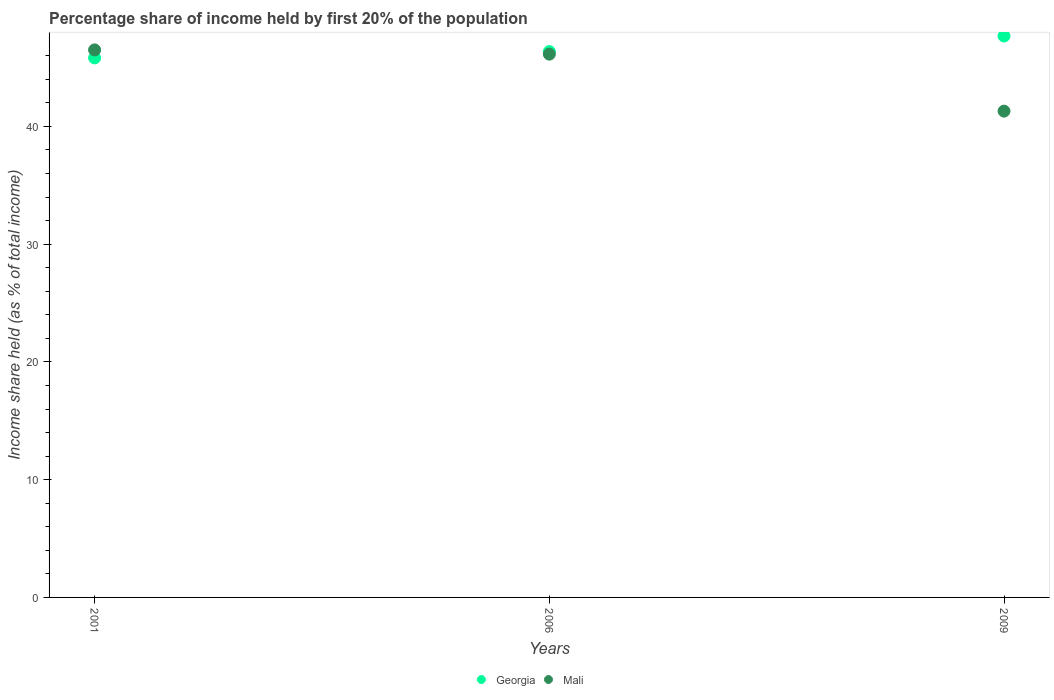How many different coloured dotlines are there?
Ensure brevity in your answer.  2. Is the number of dotlines equal to the number of legend labels?
Offer a very short reply. Yes. What is the share of income held by first 20% of the population in Georgia in 2009?
Your response must be concise. 47.68. Across all years, what is the maximum share of income held by first 20% of the population in Mali?
Make the answer very short. 46.5. Across all years, what is the minimum share of income held by first 20% of the population in Mali?
Your answer should be very brief. 41.3. What is the total share of income held by first 20% of the population in Mali in the graph?
Make the answer very short. 133.94. What is the difference between the share of income held by first 20% of the population in Mali in 2001 and that in 2009?
Give a very brief answer. 5.2. What is the difference between the share of income held by first 20% of the population in Georgia in 2006 and the share of income held by first 20% of the population in Mali in 2009?
Keep it short and to the point. 5.06. What is the average share of income held by first 20% of the population in Mali per year?
Ensure brevity in your answer.  44.65. In the year 2006, what is the difference between the share of income held by first 20% of the population in Mali and share of income held by first 20% of the population in Georgia?
Give a very brief answer. -0.22. What is the ratio of the share of income held by first 20% of the population in Georgia in 2006 to that in 2009?
Your answer should be very brief. 0.97. Is the share of income held by first 20% of the population in Georgia in 2006 less than that in 2009?
Your response must be concise. Yes. Is the difference between the share of income held by first 20% of the population in Mali in 2006 and 2009 greater than the difference between the share of income held by first 20% of the population in Georgia in 2006 and 2009?
Ensure brevity in your answer.  Yes. What is the difference between the highest and the second highest share of income held by first 20% of the population in Mali?
Make the answer very short. 0.36. What is the difference between the highest and the lowest share of income held by first 20% of the population in Mali?
Offer a terse response. 5.2. In how many years, is the share of income held by first 20% of the population in Georgia greater than the average share of income held by first 20% of the population in Georgia taken over all years?
Ensure brevity in your answer.  1. Is the sum of the share of income held by first 20% of the population in Mali in 2001 and 2009 greater than the maximum share of income held by first 20% of the population in Georgia across all years?
Your answer should be compact. Yes. Does the share of income held by first 20% of the population in Georgia monotonically increase over the years?
Provide a short and direct response. Yes. Is the share of income held by first 20% of the population in Georgia strictly less than the share of income held by first 20% of the population in Mali over the years?
Keep it short and to the point. No. How many dotlines are there?
Your answer should be very brief. 2. Does the graph contain any zero values?
Offer a very short reply. No. Does the graph contain grids?
Offer a very short reply. No. Where does the legend appear in the graph?
Your answer should be compact. Bottom center. How many legend labels are there?
Offer a terse response. 2. How are the legend labels stacked?
Ensure brevity in your answer.  Horizontal. What is the title of the graph?
Ensure brevity in your answer.  Percentage share of income held by first 20% of the population. What is the label or title of the Y-axis?
Your response must be concise. Income share held (as % of total income). What is the Income share held (as % of total income) of Georgia in 2001?
Your answer should be very brief. 45.82. What is the Income share held (as % of total income) of Mali in 2001?
Ensure brevity in your answer.  46.5. What is the Income share held (as % of total income) in Georgia in 2006?
Your response must be concise. 46.36. What is the Income share held (as % of total income) in Mali in 2006?
Offer a very short reply. 46.14. What is the Income share held (as % of total income) in Georgia in 2009?
Ensure brevity in your answer.  47.68. What is the Income share held (as % of total income) of Mali in 2009?
Provide a succinct answer. 41.3. Across all years, what is the maximum Income share held (as % of total income) in Georgia?
Offer a very short reply. 47.68. Across all years, what is the maximum Income share held (as % of total income) of Mali?
Keep it short and to the point. 46.5. Across all years, what is the minimum Income share held (as % of total income) in Georgia?
Offer a very short reply. 45.82. Across all years, what is the minimum Income share held (as % of total income) of Mali?
Offer a terse response. 41.3. What is the total Income share held (as % of total income) of Georgia in the graph?
Your response must be concise. 139.86. What is the total Income share held (as % of total income) in Mali in the graph?
Your answer should be very brief. 133.94. What is the difference between the Income share held (as % of total income) of Georgia in 2001 and that in 2006?
Make the answer very short. -0.54. What is the difference between the Income share held (as % of total income) in Mali in 2001 and that in 2006?
Keep it short and to the point. 0.36. What is the difference between the Income share held (as % of total income) in Georgia in 2001 and that in 2009?
Your answer should be compact. -1.86. What is the difference between the Income share held (as % of total income) of Georgia in 2006 and that in 2009?
Your answer should be very brief. -1.32. What is the difference between the Income share held (as % of total income) in Mali in 2006 and that in 2009?
Ensure brevity in your answer.  4.84. What is the difference between the Income share held (as % of total income) of Georgia in 2001 and the Income share held (as % of total income) of Mali in 2006?
Keep it short and to the point. -0.32. What is the difference between the Income share held (as % of total income) in Georgia in 2001 and the Income share held (as % of total income) in Mali in 2009?
Ensure brevity in your answer.  4.52. What is the difference between the Income share held (as % of total income) in Georgia in 2006 and the Income share held (as % of total income) in Mali in 2009?
Offer a terse response. 5.06. What is the average Income share held (as % of total income) in Georgia per year?
Your response must be concise. 46.62. What is the average Income share held (as % of total income) in Mali per year?
Keep it short and to the point. 44.65. In the year 2001, what is the difference between the Income share held (as % of total income) of Georgia and Income share held (as % of total income) of Mali?
Your answer should be very brief. -0.68. In the year 2006, what is the difference between the Income share held (as % of total income) of Georgia and Income share held (as % of total income) of Mali?
Your response must be concise. 0.22. In the year 2009, what is the difference between the Income share held (as % of total income) in Georgia and Income share held (as % of total income) in Mali?
Ensure brevity in your answer.  6.38. What is the ratio of the Income share held (as % of total income) in Georgia in 2001 to that in 2006?
Provide a short and direct response. 0.99. What is the ratio of the Income share held (as % of total income) in Mali in 2001 to that in 2006?
Ensure brevity in your answer.  1.01. What is the ratio of the Income share held (as % of total income) of Georgia in 2001 to that in 2009?
Your answer should be very brief. 0.96. What is the ratio of the Income share held (as % of total income) in Mali in 2001 to that in 2009?
Your response must be concise. 1.13. What is the ratio of the Income share held (as % of total income) of Georgia in 2006 to that in 2009?
Ensure brevity in your answer.  0.97. What is the ratio of the Income share held (as % of total income) in Mali in 2006 to that in 2009?
Offer a very short reply. 1.12. What is the difference between the highest and the second highest Income share held (as % of total income) in Georgia?
Offer a terse response. 1.32. What is the difference between the highest and the second highest Income share held (as % of total income) of Mali?
Ensure brevity in your answer.  0.36. What is the difference between the highest and the lowest Income share held (as % of total income) of Georgia?
Keep it short and to the point. 1.86. What is the difference between the highest and the lowest Income share held (as % of total income) in Mali?
Your answer should be very brief. 5.2. 